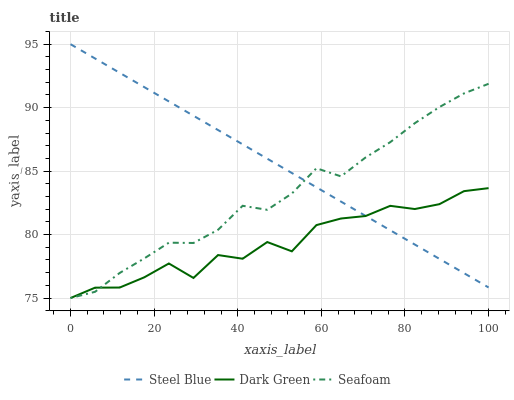Does Dark Green have the minimum area under the curve?
Answer yes or no. Yes. Does Steel Blue have the maximum area under the curve?
Answer yes or no. Yes. Does Steel Blue have the minimum area under the curve?
Answer yes or no. No. Does Dark Green have the maximum area under the curve?
Answer yes or no. No. Is Steel Blue the smoothest?
Answer yes or no. Yes. Is Dark Green the roughest?
Answer yes or no. Yes. Is Dark Green the smoothest?
Answer yes or no. No. Is Steel Blue the roughest?
Answer yes or no. No. Does Seafoam have the lowest value?
Answer yes or no. Yes. Does Steel Blue have the lowest value?
Answer yes or no. No. Does Steel Blue have the highest value?
Answer yes or no. Yes. Does Dark Green have the highest value?
Answer yes or no. No. Does Seafoam intersect Dark Green?
Answer yes or no. Yes. Is Seafoam less than Dark Green?
Answer yes or no. No. Is Seafoam greater than Dark Green?
Answer yes or no. No. 